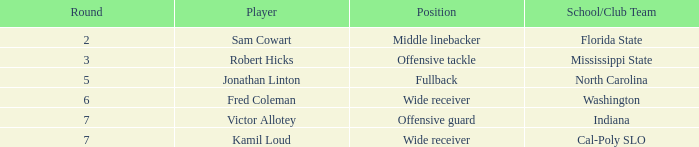Which athlete has a round below 5 and is part of a school/club team at florida state? Sam Cowart. 